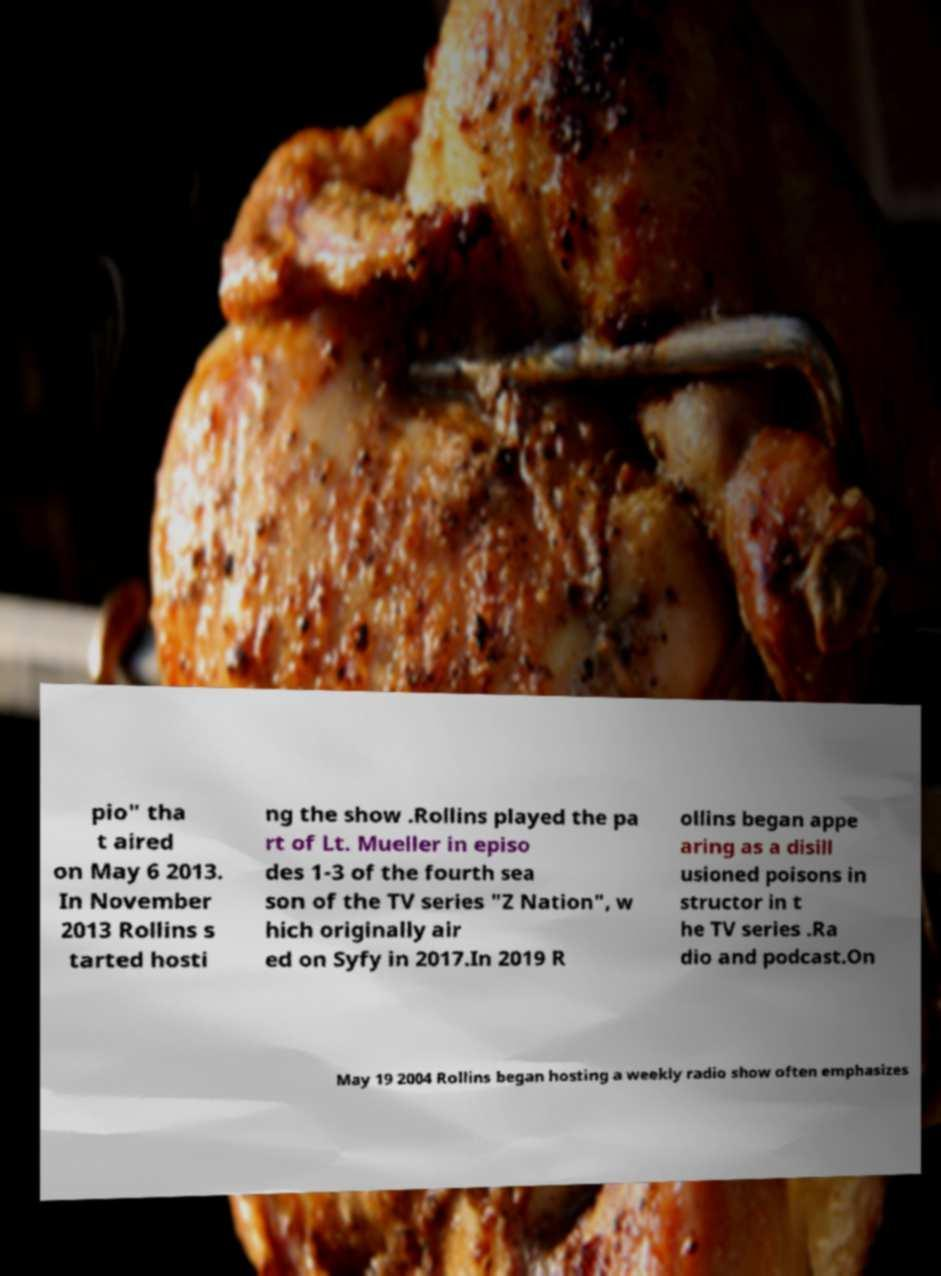What messages or text are displayed in this image? I need them in a readable, typed format. pio" tha t aired on May 6 2013. In November 2013 Rollins s tarted hosti ng the show .Rollins played the pa rt of Lt. Mueller in episo des 1-3 of the fourth sea son of the TV series "Z Nation", w hich originally air ed on Syfy in 2017.In 2019 R ollins began appe aring as a disill usioned poisons in structor in t he TV series .Ra dio and podcast.On May 19 2004 Rollins began hosting a weekly radio show often emphasizes 